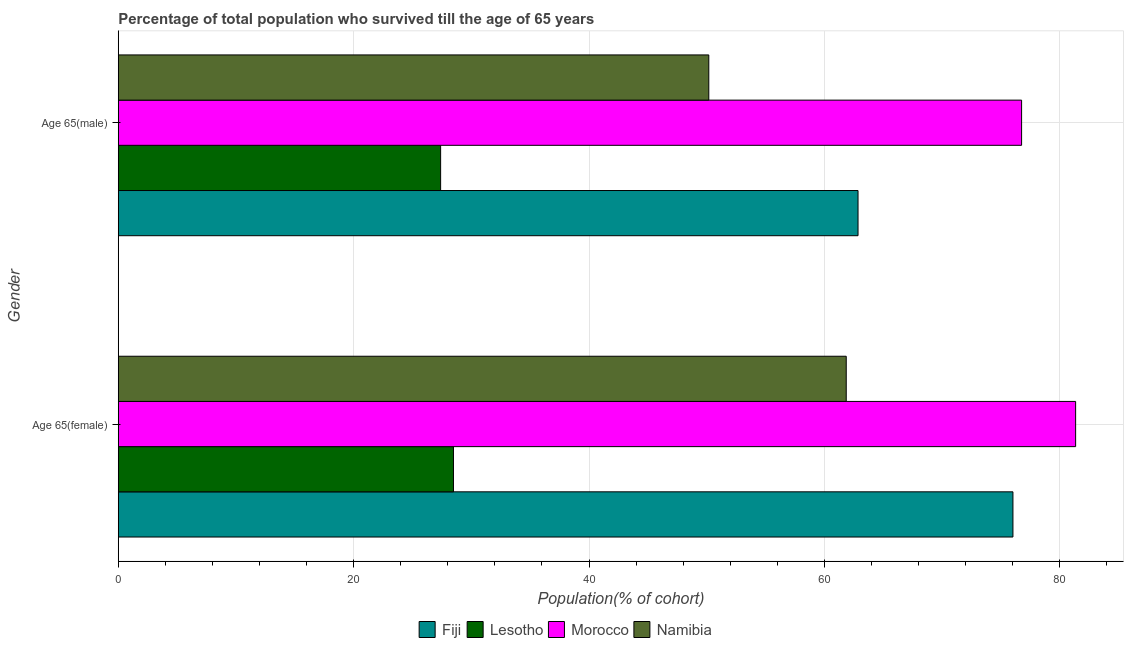How many different coloured bars are there?
Provide a succinct answer. 4. How many groups of bars are there?
Ensure brevity in your answer.  2. Are the number of bars on each tick of the Y-axis equal?
Offer a very short reply. Yes. How many bars are there on the 2nd tick from the top?
Your response must be concise. 4. What is the label of the 1st group of bars from the top?
Give a very brief answer. Age 65(male). What is the percentage of female population who survived till age of 65 in Lesotho?
Keep it short and to the point. 28.48. Across all countries, what is the maximum percentage of male population who survived till age of 65?
Your answer should be very brief. 76.76. Across all countries, what is the minimum percentage of female population who survived till age of 65?
Offer a terse response. 28.48. In which country was the percentage of female population who survived till age of 65 maximum?
Offer a very short reply. Morocco. In which country was the percentage of male population who survived till age of 65 minimum?
Your answer should be very brief. Lesotho. What is the total percentage of male population who survived till age of 65 in the graph?
Ensure brevity in your answer.  217.2. What is the difference between the percentage of male population who survived till age of 65 in Fiji and that in Morocco?
Keep it short and to the point. -13.9. What is the difference between the percentage of female population who survived till age of 65 in Fiji and the percentage of male population who survived till age of 65 in Morocco?
Make the answer very short. -0.74. What is the average percentage of male population who survived till age of 65 per country?
Give a very brief answer. 54.3. What is the difference between the percentage of female population who survived till age of 65 and percentage of male population who survived till age of 65 in Morocco?
Keep it short and to the point. 4.59. In how many countries, is the percentage of male population who survived till age of 65 greater than 48 %?
Keep it short and to the point. 3. What is the ratio of the percentage of male population who survived till age of 65 in Morocco to that in Lesotho?
Provide a succinct answer. 2.8. Is the percentage of female population who survived till age of 65 in Fiji less than that in Namibia?
Your answer should be very brief. No. What does the 2nd bar from the top in Age 65(male) represents?
Your answer should be very brief. Morocco. What does the 3rd bar from the bottom in Age 65(female) represents?
Keep it short and to the point. Morocco. How many bars are there?
Offer a terse response. 8. How many countries are there in the graph?
Provide a short and direct response. 4. What is the difference between two consecutive major ticks on the X-axis?
Offer a terse response. 20. Are the values on the major ticks of X-axis written in scientific E-notation?
Provide a short and direct response. No. Does the graph contain any zero values?
Give a very brief answer. No. Where does the legend appear in the graph?
Offer a very short reply. Bottom center. How many legend labels are there?
Offer a very short reply. 4. What is the title of the graph?
Keep it short and to the point. Percentage of total population who survived till the age of 65 years. What is the label or title of the X-axis?
Offer a terse response. Population(% of cohort). What is the Population(% of cohort) in Fiji in Age 65(female)?
Keep it short and to the point. 76.03. What is the Population(% of cohort) in Lesotho in Age 65(female)?
Provide a short and direct response. 28.48. What is the Population(% of cohort) in Morocco in Age 65(female)?
Your answer should be very brief. 81.35. What is the Population(% of cohort) in Namibia in Age 65(female)?
Offer a terse response. 61.86. What is the Population(% of cohort) of Fiji in Age 65(male)?
Provide a short and direct response. 62.86. What is the Population(% of cohort) of Lesotho in Age 65(male)?
Ensure brevity in your answer.  27.39. What is the Population(% of cohort) of Morocco in Age 65(male)?
Provide a short and direct response. 76.76. What is the Population(% of cohort) in Namibia in Age 65(male)?
Offer a terse response. 50.18. Across all Gender, what is the maximum Population(% of cohort) of Fiji?
Offer a terse response. 76.03. Across all Gender, what is the maximum Population(% of cohort) in Lesotho?
Your answer should be compact. 28.48. Across all Gender, what is the maximum Population(% of cohort) of Morocco?
Your response must be concise. 81.35. Across all Gender, what is the maximum Population(% of cohort) in Namibia?
Ensure brevity in your answer.  61.86. Across all Gender, what is the minimum Population(% of cohort) in Fiji?
Provide a short and direct response. 62.86. Across all Gender, what is the minimum Population(% of cohort) of Lesotho?
Offer a very short reply. 27.39. Across all Gender, what is the minimum Population(% of cohort) of Morocco?
Keep it short and to the point. 76.76. Across all Gender, what is the minimum Population(% of cohort) in Namibia?
Your answer should be compact. 50.18. What is the total Population(% of cohort) of Fiji in the graph?
Provide a short and direct response. 138.89. What is the total Population(% of cohort) of Lesotho in the graph?
Provide a succinct answer. 55.87. What is the total Population(% of cohort) in Morocco in the graph?
Offer a very short reply. 158.11. What is the total Population(% of cohort) in Namibia in the graph?
Give a very brief answer. 112.04. What is the difference between the Population(% of cohort) in Fiji in Age 65(female) and that in Age 65(male)?
Provide a short and direct response. 13.16. What is the difference between the Population(% of cohort) of Lesotho in Age 65(female) and that in Age 65(male)?
Give a very brief answer. 1.09. What is the difference between the Population(% of cohort) in Morocco in Age 65(female) and that in Age 65(male)?
Provide a short and direct response. 4.59. What is the difference between the Population(% of cohort) in Namibia in Age 65(female) and that in Age 65(male)?
Ensure brevity in your answer.  11.68. What is the difference between the Population(% of cohort) in Fiji in Age 65(female) and the Population(% of cohort) in Lesotho in Age 65(male)?
Offer a terse response. 48.63. What is the difference between the Population(% of cohort) in Fiji in Age 65(female) and the Population(% of cohort) in Morocco in Age 65(male)?
Offer a very short reply. -0.74. What is the difference between the Population(% of cohort) in Fiji in Age 65(female) and the Population(% of cohort) in Namibia in Age 65(male)?
Provide a succinct answer. 25.85. What is the difference between the Population(% of cohort) of Lesotho in Age 65(female) and the Population(% of cohort) of Morocco in Age 65(male)?
Give a very brief answer. -48.28. What is the difference between the Population(% of cohort) in Lesotho in Age 65(female) and the Population(% of cohort) in Namibia in Age 65(male)?
Keep it short and to the point. -21.7. What is the difference between the Population(% of cohort) of Morocco in Age 65(female) and the Population(% of cohort) of Namibia in Age 65(male)?
Offer a very short reply. 31.17. What is the average Population(% of cohort) of Fiji per Gender?
Provide a succinct answer. 69.44. What is the average Population(% of cohort) of Lesotho per Gender?
Provide a succinct answer. 27.94. What is the average Population(% of cohort) of Morocco per Gender?
Your answer should be compact. 79.06. What is the average Population(% of cohort) in Namibia per Gender?
Offer a very short reply. 56.02. What is the difference between the Population(% of cohort) of Fiji and Population(% of cohort) of Lesotho in Age 65(female)?
Make the answer very short. 47.54. What is the difference between the Population(% of cohort) in Fiji and Population(% of cohort) in Morocco in Age 65(female)?
Give a very brief answer. -5.33. What is the difference between the Population(% of cohort) of Fiji and Population(% of cohort) of Namibia in Age 65(female)?
Make the answer very short. 14.17. What is the difference between the Population(% of cohort) of Lesotho and Population(% of cohort) of Morocco in Age 65(female)?
Make the answer very short. -52.87. What is the difference between the Population(% of cohort) of Lesotho and Population(% of cohort) of Namibia in Age 65(female)?
Make the answer very short. -33.38. What is the difference between the Population(% of cohort) in Morocco and Population(% of cohort) in Namibia in Age 65(female)?
Your answer should be very brief. 19.49. What is the difference between the Population(% of cohort) in Fiji and Population(% of cohort) in Lesotho in Age 65(male)?
Offer a terse response. 35.47. What is the difference between the Population(% of cohort) of Fiji and Population(% of cohort) of Morocco in Age 65(male)?
Offer a very short reply. -13.9. What is the difference between the Population(% of cohort) in Fiji and Population(% of cohort) in Namibia in Age 65(male)?
Your response must be concise. 12.68. What is the difference between the Population(% of cohort) in Lesotho and Population(% of cohort) in Morocco in Age 65(male)?
Provide a short and direct response. -49.37. What is the difference between the Population(% of cohort) in Lesotho and Population(% of cohort) in Namibia in Age 65(male)?
Make the answer very short. -22.79. What is the difference between the Population(% of cohort) of Morocco and Population(% of cohort) of Namibia in Age 65(male)?
Provide a short and direct response. 26.58. What is the ratio of the Population(% of cohort) of Fiji in Age 65(female) to that in Age 65(male)?
Provide a succinct answer. 1.21. What is the ratio of the Population(% of cohort) of Lesotho in Age 65(female) to that in Age 65(male)?
Ensure brevity in your answer.  1.04. What is the ratio of the Population(% of cohort) of Morocco in Age 65(female) to that in Age 65(male)?
Ensure brevity in your answer.  1.06. What is the ratio of the Population(% of cohort) in Namibia in Age 65(female) to that in Age 65(male)?
Offer a terse response. 1.23. What is the difference between the highest and the second highest Population(% of cohort) in Fiji?
Offer a very short reply. 13.16. What is the difference between the highest and the second highest Population(% of cohort) of Lesotho?
Ensure brevity in your answer.  1.09. What is the difference between the highest and the second highest Population(% of cohort) in Morocco?
Offer a terse response. 4.59. What is the difference between the highest and the second highest Population(% of cohort) in Namibia?
Make the answer very short. 11.68. What is the difference between the highest and the lowest Population(% of cohort) in Fiji?
Keep it short and to the point. 13.16. What is the difference between the highest and the lowest Population(% of cohort) in Lesotho?
Provide a short and direct response. 1.09. What is the difference between the highest and the lowest Population(% of cohort) of Morocco?
Give a very brief answer. 4.59. What is the difference between the highest and the lowest Population(% of cohort) of Namibia?
Make the answer very short. 11.68. 